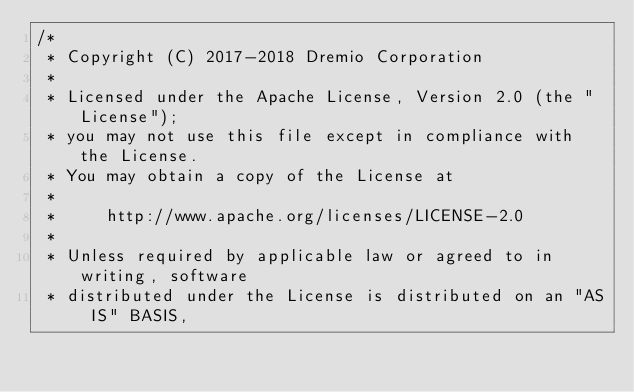<code> <loc_0><loc_0><loc_500><loc_500><_JavaScript_>/*
 * Copyright (C) 2017-2018 Dremio Corporation
 *
 * Licensed under the Apache License, Version 2.0 (the "License");
 * you may not use this file except in compliance with the License.
 * You may obtain a copy of the License at
 *
 *     http://www.apache.org/licenses/LICENSE-2.0
 *
 * Unless required by applicable law or agreed to in writing, software
 * distributed under the License is distributed on an "AS IS" BASIS,</code> 